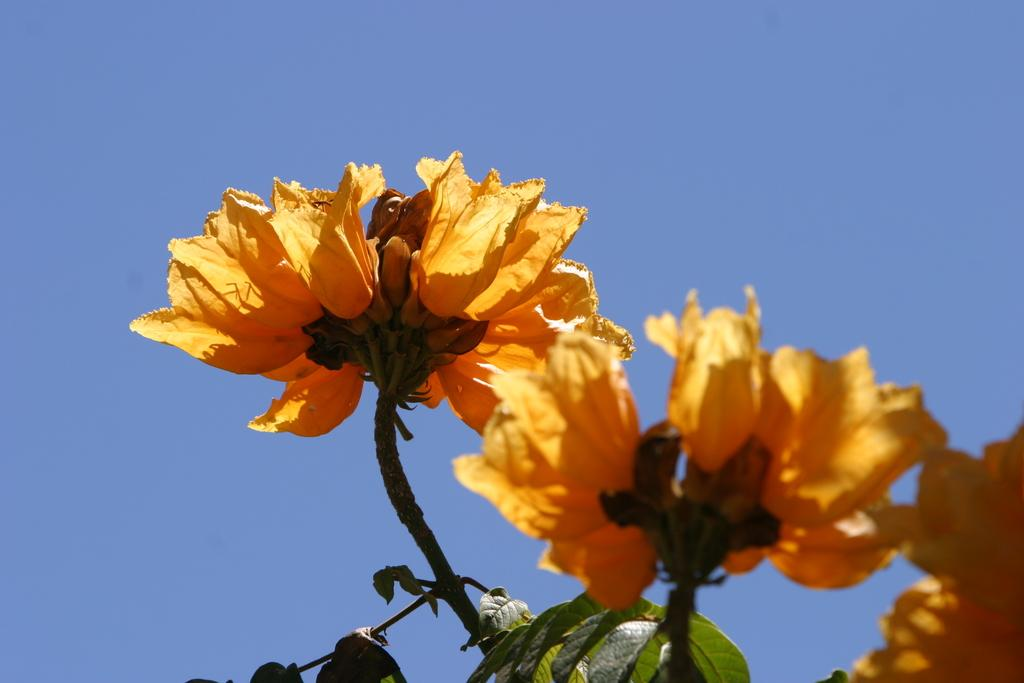What type of living organisms can be seen in the image? There are flowers in the image. Can you describe the color of the flowers? The flowers are pale orange in color. What else is visible in the image besides the flowers? There are leaves in the image. What part of the natural environment is visible in the image? The sky is visible in the image. How many bikes are parked next to the flowers in the image? There are no bikes present in the image. What type of behavior can be observed in the flowers in the image? The flowers in the image are not capable of exhibiting behavior, as they are inanimate objects. 